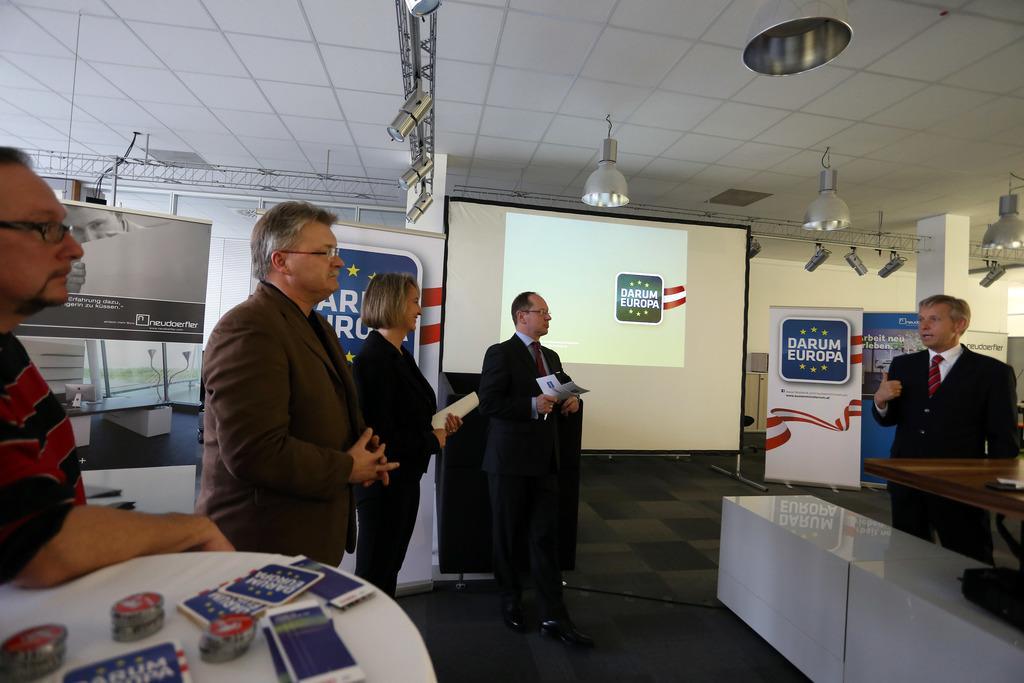Please provide a concise description of this image. In the foreground, I can see five persons are standing on the floor in front of tables, on which some objects are there. In the background, I can see screens, boards, lights on a rooftop, a wall and metal objects. This image might be taken in a hall. 